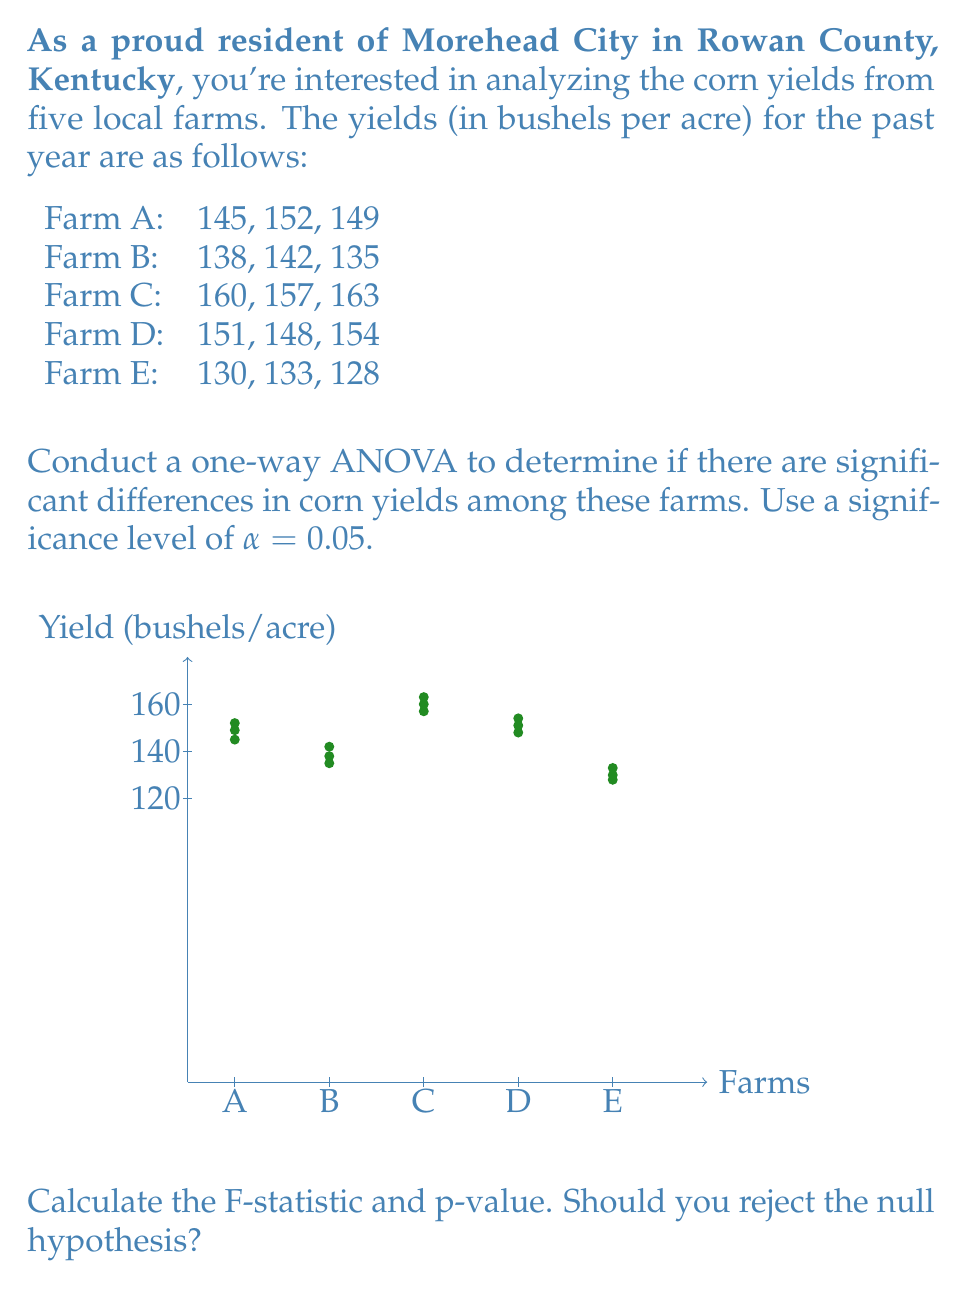Give your solution to this math problem. Let's approach this step-by-step:

1) First, we need to calculate the mean for each farm:
   Farm A: $\bar{x}_A = \frac{145 + 152 + 149}{3} = 148.67$
   Farm B: $\bar{x}_B = \frac{138 + 142 + 135}{3} = 138.33$
   Farm C: $\bar{x}_C = \frac{160 + 157 + 163}{3} = 160.00$
   Farm D: $\bar{x}_D = \frac{151 + 148 + 154}{3} = 151.00$
   Farm E: $\bar{x}_E = \frac{130 + 133 + 128}{3} = 130.33$

2) Calculate the grand mean:
   $\bar{x} = \frac{148.67 + 138.33 + 160.00 + 151.00 + 130.33}{5} = 145.67$

3) Calculate the Sum of Squares Between (SSB):
   $SSB = 3[(148.67 - 145.67)^2 + (138.33 - 145.67)^2 + (160.00 - 145.67)^2 + (151.00 - 145.67)^2 + (130.33 - 145.67)^2] = 1640.67$

4) Calculate the Sum of Squares Within (SSW):
   $SSW = (145-148.67)^2 + (152-148.67)^2 + (149-148.67)^2 + ... + (128-130.33)^2 = 226.00$

5) Calculate degrees of freedom:
   $df_{between} = 5 - 1 = 4$
   $df_{within} = 5(3 - 1) = 10$

6) Calculate Mean Square Between (MSB) and Mean Square Within (MSW):
   $MSB = \frac{SSB}{df_{between}} = \frac{1640.67}{4} = 410.17$
   $MSW = \frac{SSW}{df_{within}} = \frac{226.00}{10} = 22.60$

7) Calculate the F-statistic:
   $F = \frac{MSB}{MSW} = \frac{410.17}{22.60} = 18.15$

8) Find the critical F-value:
   For $\alpha = 0.05$, $df_{between} = 4$, and $df_{within} = 10$, the critical F-value is approximately 3.48.

9) Calculate the p-value:
   Using an F-distribution calculator, we find that the p-value for F = 18.15 with df1 = 4 and df2 = 10 is approximately 0.0001.

Since the calculated F-statistic (18.15) is greater than the critical F-value (3.48), and the p-value (0.0001) is less than the significance level (0.05), we reject the null hypothesis.
Answer: Reject the null hypothesis; F(4,10) = 18.15, p = 0.0001 < 0.05 